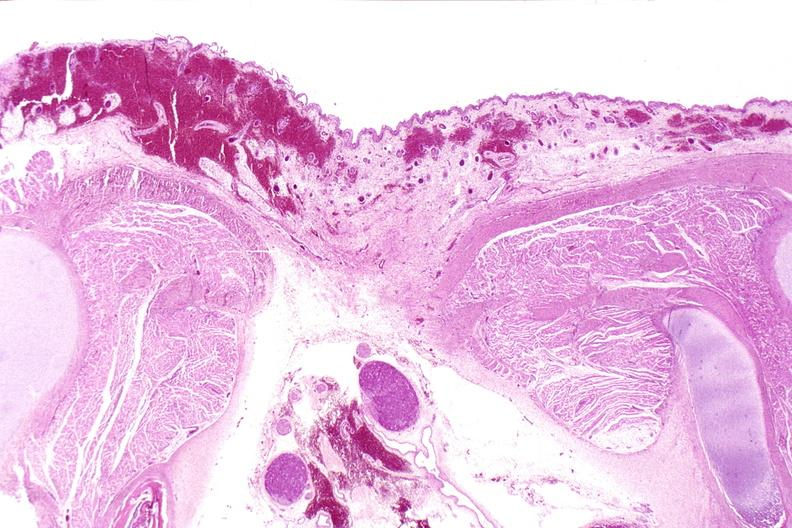s nervous present?
Answer the question using a single word or phrase. Yes 